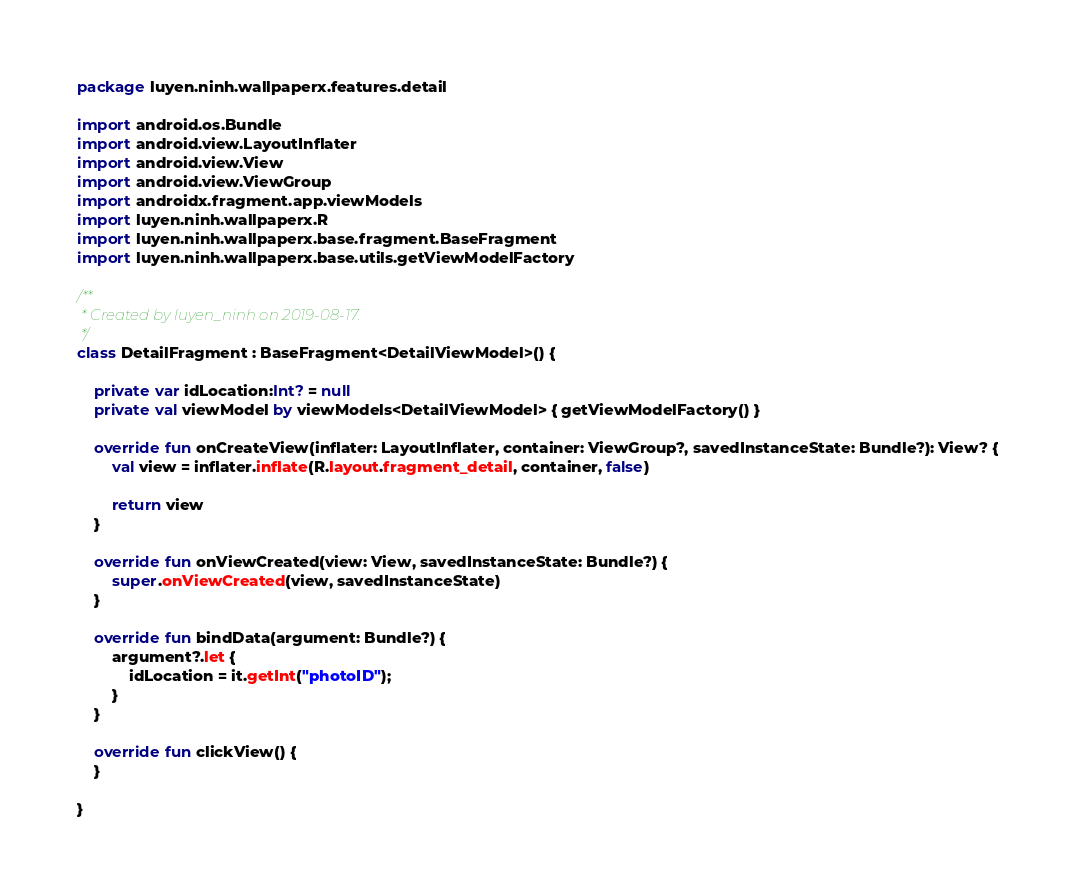Convert code to text. <code><loc_0><loc_0><loc_500><loc_500><_Kotlin_>package luyen.ninh.wallpaperx.features.detail

import android.os.Bundle
import android.view.LayoutInflater
import android.view.View
import android.view.ViewGroup
import androidx.fragment.app.viewModels
import luyen.ninh.wallpaperx.R
import luyen.ninh.wallpaperx.base.fragment.BaseFragment
import luyen.ninh.wallpaperx.base.utils.getViewModelFactory

/**
 * Created by luyen_ninh on 2019-08-17.
 */
class DetailFragment : BaseFragment<DetailViewModel>() {

    private var idLocation:Int? = null
    private val viewModel by viewModels<DetailViewModel> { getViewModelFactory() }

    override fun onCreateView(inflater: LayoutInflater, container: ViewGroup?, savedInstanceState: Bundle?): View? {
        val view = inflater.inflate(R.layout.fragment_detail, container, false)

        return view
    }

    override fun onViewCreated(view: View, savedInstanceState: Bundle?) {
        super.onViewCreated(view, savedInstanceState)
    }

    override fun bindData(argument: Bundle?) {
        argument?.let {
            idLocation = it.getInt("photoID");
        }
    }

    override fun clickView() {
    }

}</code> 